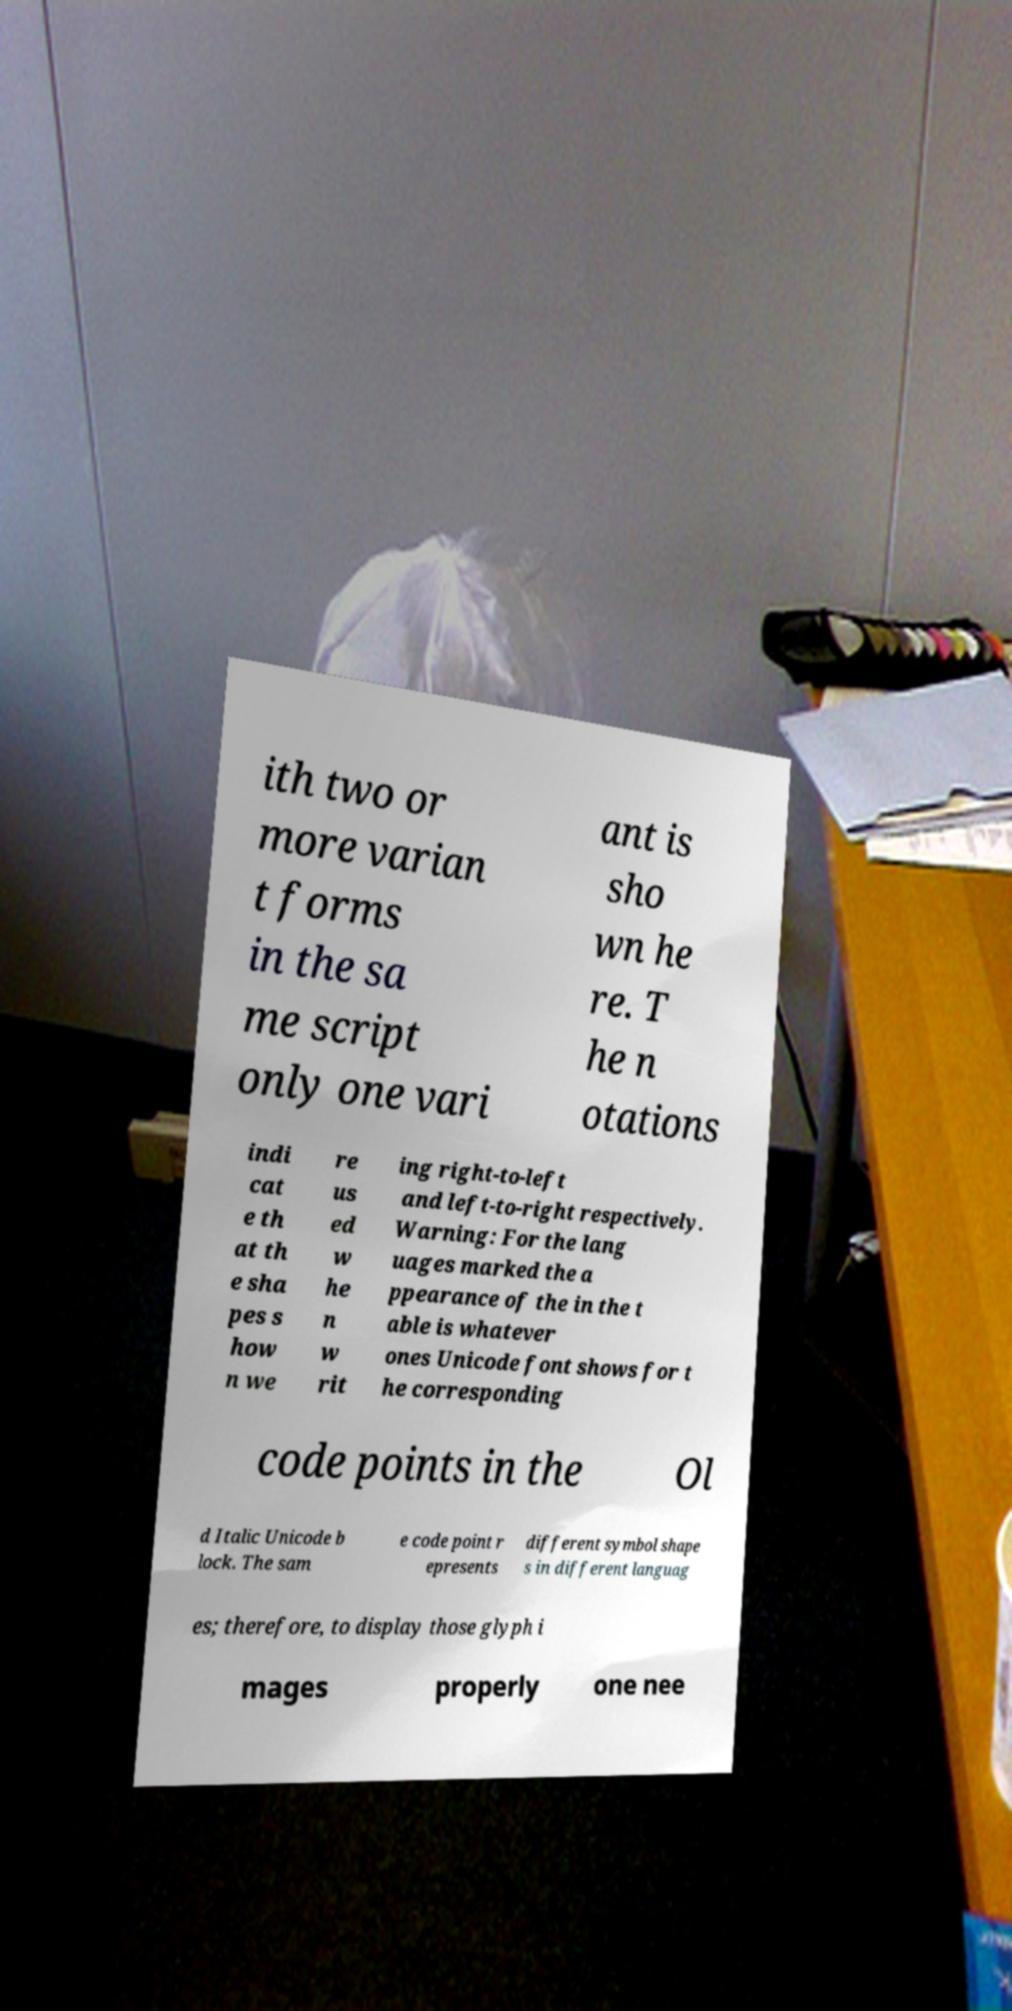Can you accurately transcribe the text from the provided image for me? ith two or more varian t forms in the sa me script only one vari ant is sho wn he re. T he n otations indi cat e th at th e sha pes s how n we re us ed w he n w rit ing right-to-left and left-to-right respectively. Warning: For the lang uages marked the a ppearance of the in the t able is whatever ones Unicode font shows for t he corresponding code points in the Ol d Italic Unicode b lock. The sam e code point r epresents different symbol shape s in different languag es; therefore, to display those glyph i mages properly one nee 